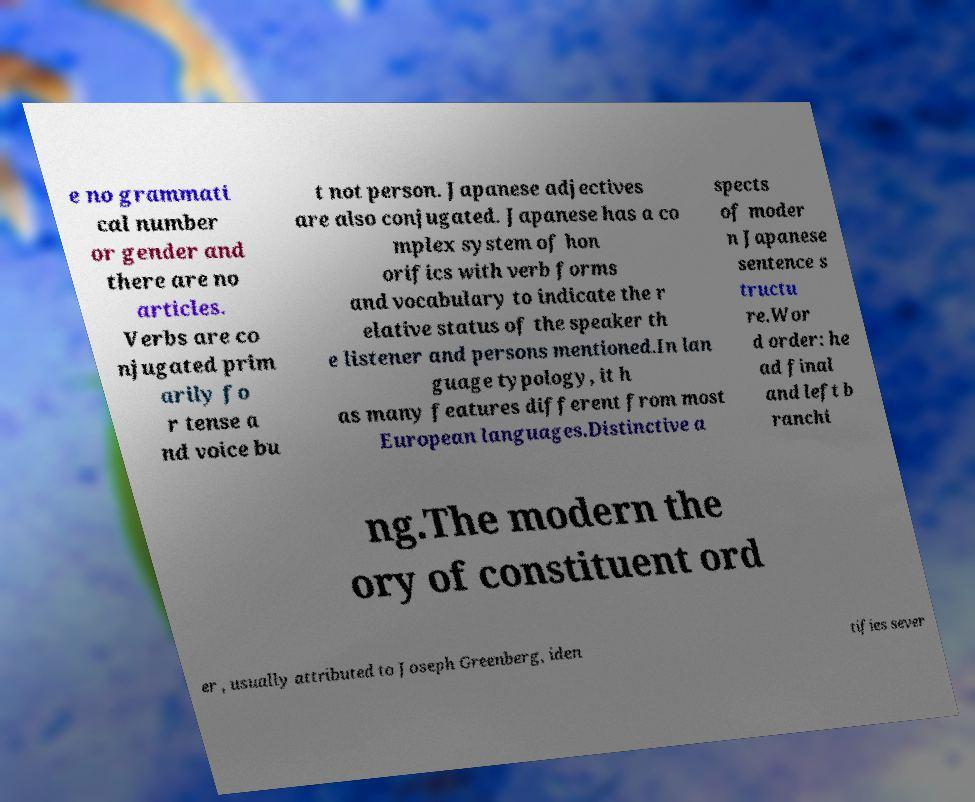Can you read and provide the text displayed in the image?This photo seems to have some interesting text. Can you extract and type it out for me? e no grammati cal number or gender and there are no articles. Verbs are co njugated prim arily fo r tense a nd voice bu t not person. Japanese adjectives are also conjugated. Japanese has a co mplex system of hon orifics with verb forms and vocabulary to indicate the r elative status of the speaker th e listener and persons mentioned.In lan guage typology, it h as many features different from most European languages.Distinctive a spects of moder n Japanese sentence s tructu re.Wor d order: he ad final and left b ranchi ng.The modern the ory of constituent ord er , usually attributed to Joseph Greenberg, iden tifies sever 